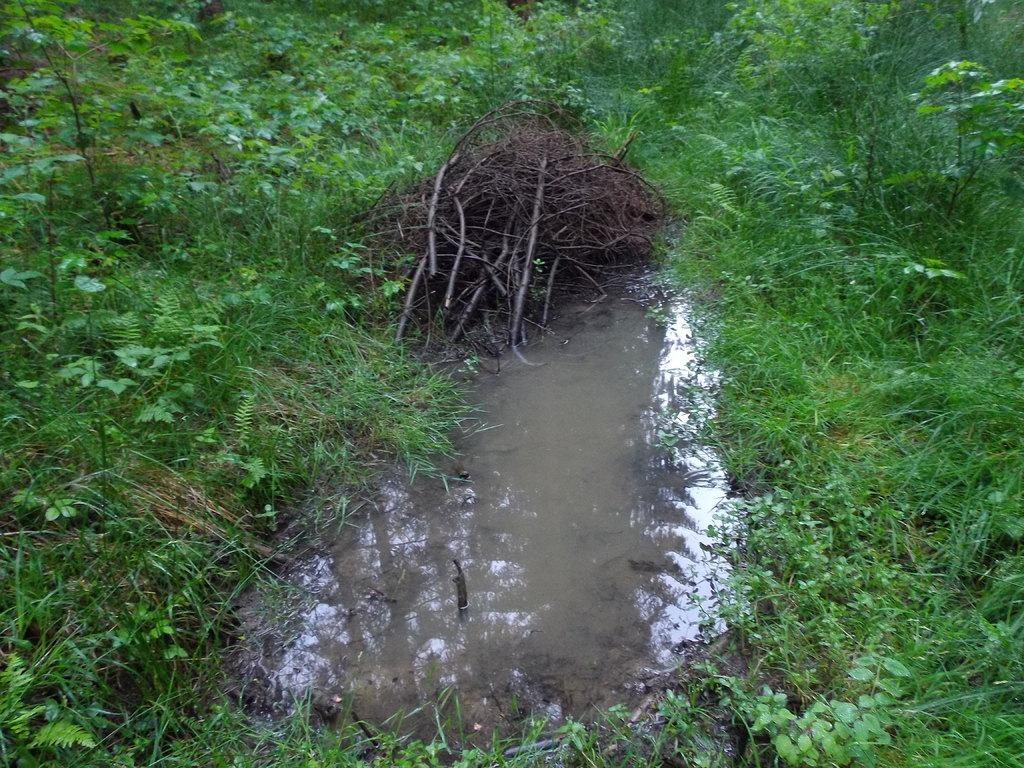What is the main feature in the image? There is a muddy pool in the image. What type of vegetation surrounds the pool? There is grass and plants around the pool. What other objects can be seen in the image? There are sticks visible in the image. What type of hope can be seen growing near the pool? There is no hope present in the image; it is a muddy pool surrounded by grass, plants, and sticks. 